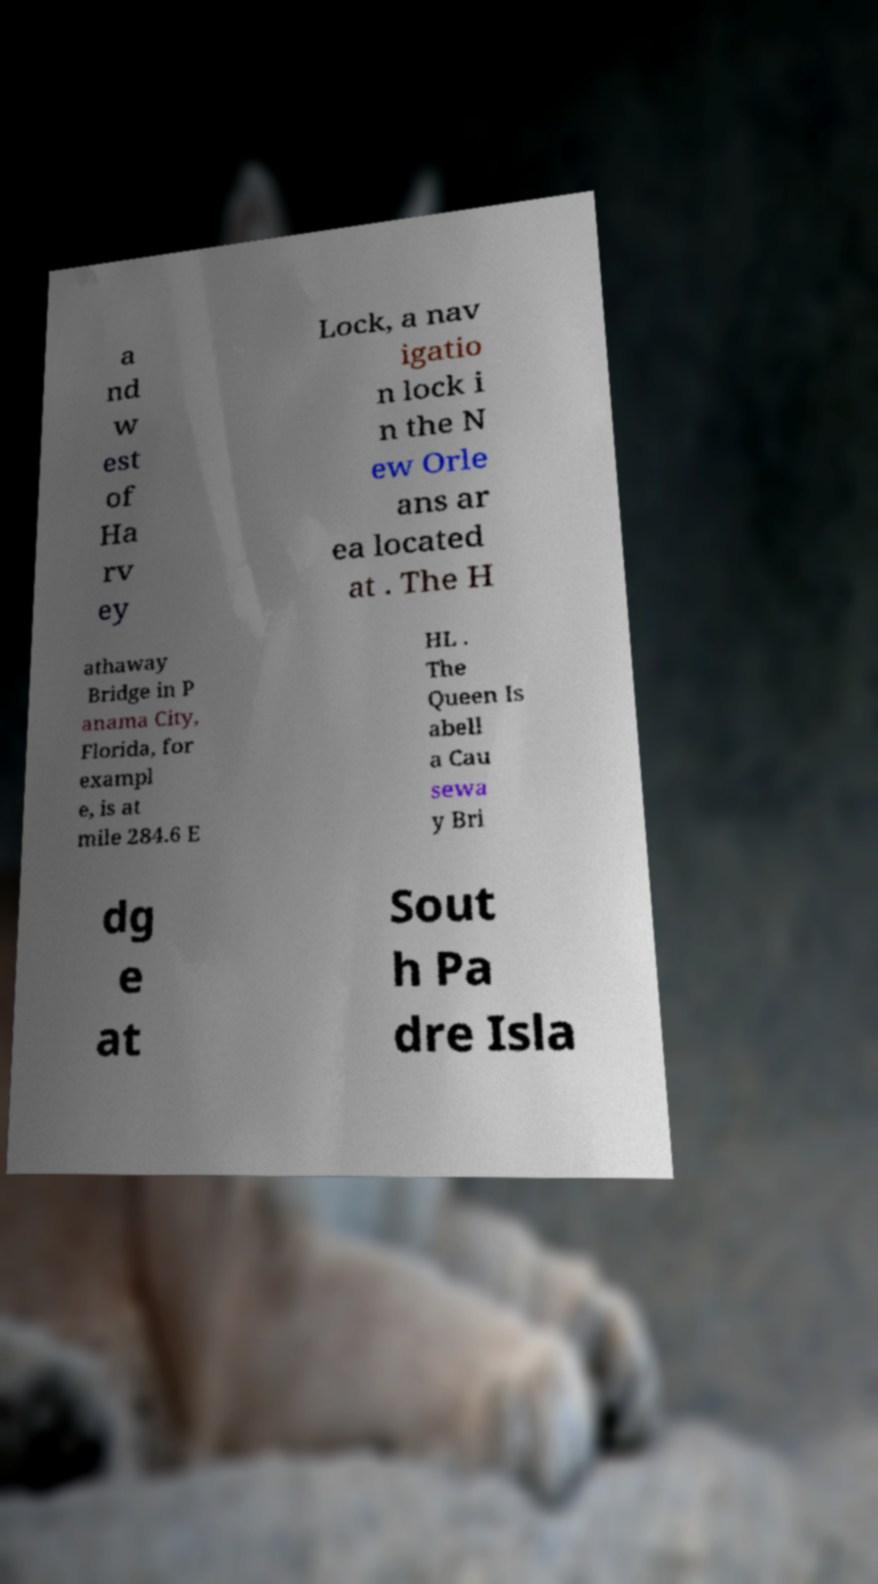I need the written content from this picture converted into text. Can you do that? a nd w est of Ha rv ey Lock, a nav igatio n lock i n the N ew Orle ans ar ea located at . The H athaway Bridge in P anama City, Florida, for exampl e, is at mile 284.6 E HL . The Queen Is abell a Cau sewa y Bri dg e at Sout h Pa dre Isla 